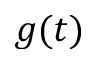Convert formula to latex. <formula><loc_0><loc_0><loc_500><loc_500>g ( t )</formula> 